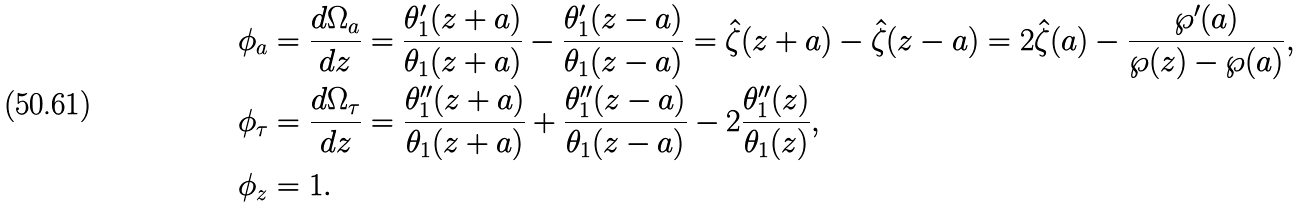<formula> <loc_0><loc_0><loc_500><loc_500>\phi _ { a } & = \frac { d \Omega _ { a } } { d z } = \frac { \theta _ { 1 } ^ { \prime } ( z + a ) } { \theta _ { 1 } ( z + a ) } - \frac { \theta _ { 1 } ^ { \prime } ( z - a ) } { \theta _ { 1 } ( z - a ) } = \hat { \zeta } ( z + a ) - \hat { \zeta } ( z - a ) = 2 \hat { \zeta } ( a ) - \frac { \wp ^ { \prime } ( a ) } { \wp ( z ) - \wp ( a ) } , \\ \phi _ { \tau } & = \frac { d \Omega _ { \tau } } { d z } = \frac { \theta _ { 1 } ^ { \prime \prime } ( z + a ) } { \theta _ { 1 } ( z + a ) } + \frac { \theta _ { 1 } ^ { \prime \prime } ( z - a ) } { \theta _ { 1 } ( z - a ) } - 2 \frac { \theta _ { 1 } ^ { \prime \prime } ( z ) } { \theta _ { 1 } ( z ) } , \\ \phi _ { z } & = 1 .</formula> 